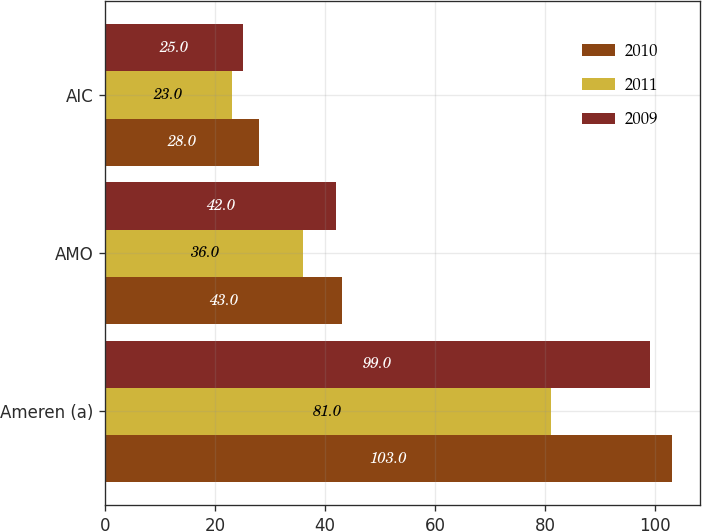<chart> <loc_0><loc_0><loc_500><loc_500><stacked_bar_chart><ecel><fcel>Ameren (a)<fcel>AMO<fcel>AIC<nl><fcel>2010<fcel>103<fcel>43<fcel>28<nl><fcel>2011<fcel>81<fcel>36<fcel>23<nl><fcel>2009<fcel>99<fcel>42<fcel>25<nl></chart> 